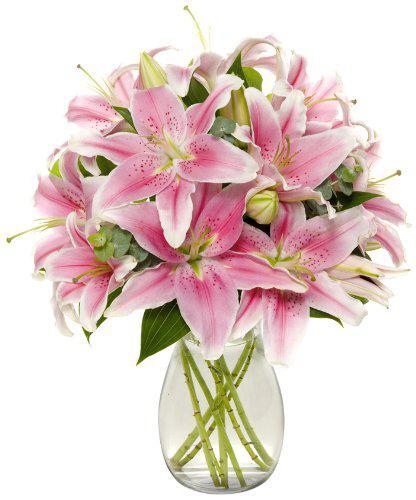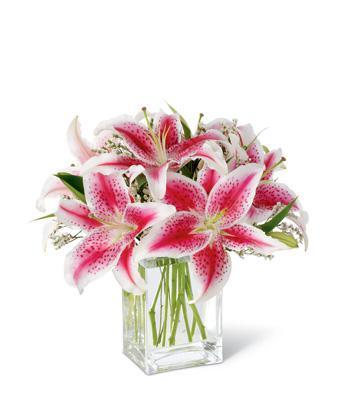The first image is the image on the left, the second image is the image on the right. For the images shown, is this caption "One arrangement showcases white flowers and the other contains pink flowers." true? Answer yes or no. No. 